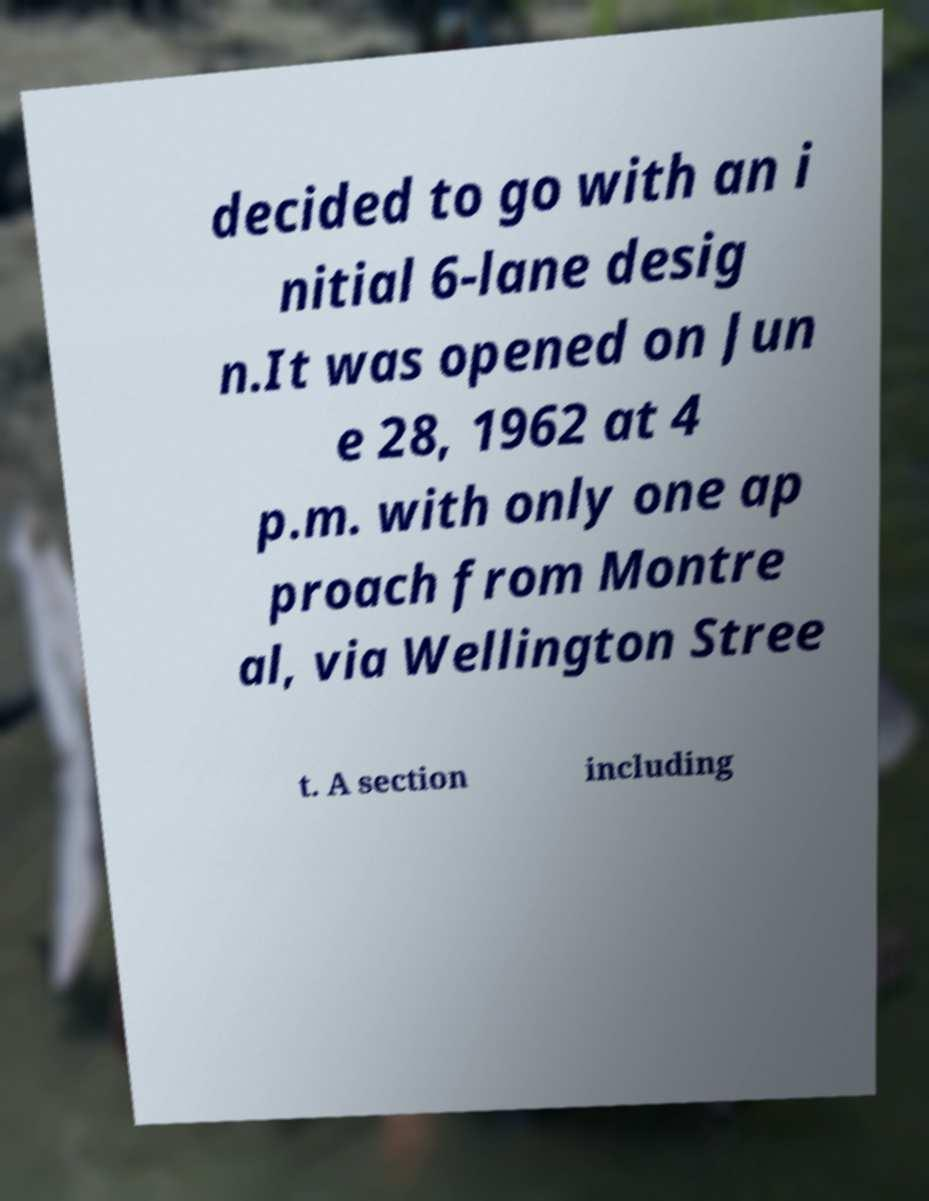Please identify and transcribe the text found in this image. decided to go with an i nitial 6-lane desig n.It was opened on Jun e 28, 1962 at 4 p.m. with only one ap proach from Montre al, via Wellington Stree t. A section including 